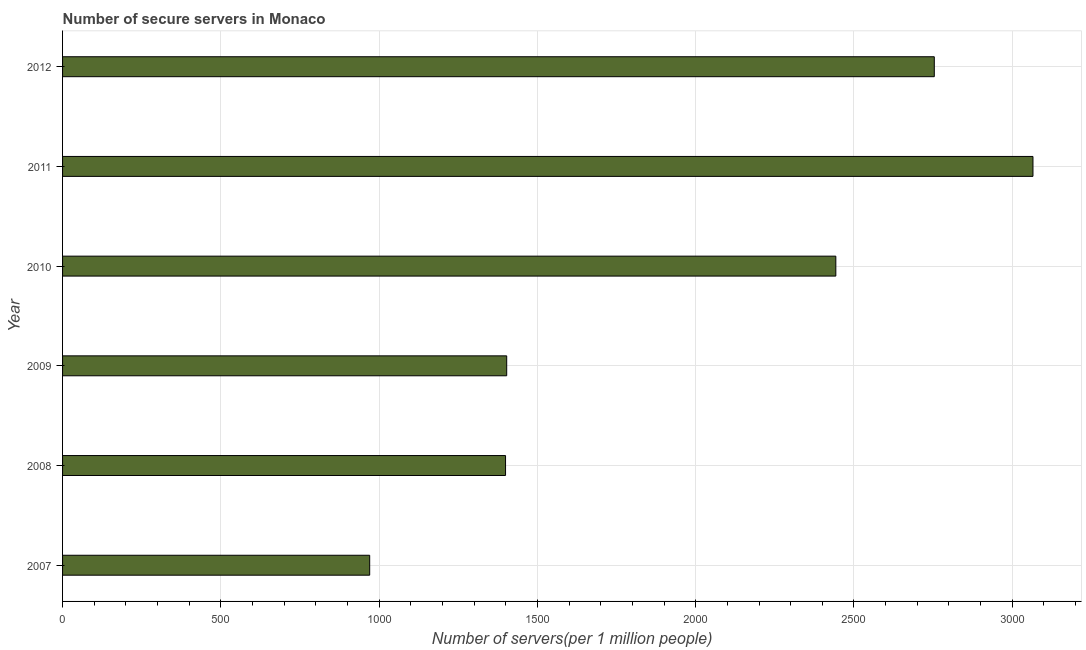Does the graph contain any zero values?
Make the answer very short. No. Does the graph contain grids?
Offer a terse response. Yes. What is the title of the graph?
Give a very brief answer. Number of secure servers in Monaco. What is the label or title of the X-axis?
Offer a very short reply. Number of servers(per 1 million people). What is the number of secure internet servers in 2008?
Keep it short and to the point. 1399.35. Across all years, what is the maximum number of secure internet servers?
Provide a succinct answer. 3065.42. Across all years, what is the minimum number of secure internet servers?
Make the answer very short. 970.15. In which year was the number of secure internet servers minimum?
Offer a terse response. 2007. What is the sum of the number of secure internet servers?
Make the answer very short. 1.20e+04. What is the difference between the number of secure internet servers in 2011 and 2012?
Offer a terse response. 311.71. What is the average number of secure internet servers per year?
Offer a very short reply. 2005.71. What is the median number of secure internet servers?
Give a very brief answer. 1922.83. In how many years, is the number of secure internet servers greater than 1900 ?
Keep it short and to the point. 3. What is the ratio of the number of secure internet servers in 2008 to that in 2012?
Your answer should be compact. 0.51. Is the number of secure internet servers in 2007 less than that in 2011?
Ensure brevity in your answer.  Yes. What is the difference between the highest and the second highest number of secure internet servers?
Your answer should be very brief. 311.71. Is the sum of the number of secure internet servers in 2010 and 2012 greater than the maximum number of secure internet servers across all years?
Ensure brevity in your answer.  Yes. What is the difference between the highest and the lowest number of secure internet servers?
Make the answer very short. 2095.27. How many bars are there?
Offer a terse response. 6. How many years are there in the graph?
Your answer should be very brief. 6. What is the Number of servers(per 1 million people) in 2007?
Offer a very short reply. 970.15. What is the Number of servers(per 1 million people) of 2008?
Keep it short and to the point. 1399.35. What is the Number of servers(per 1 million people) of 2009?
Offer a terse response. 1402.99. What is the Number of servers(per 1 million people) in 2010?
Give a very brief answer. 2442.67. What is the Number of servers(per 1 million people) in 2011?
Ensure brevity in your answer.  3065.42. What is the Number of servers(per 1 million people) of 2012?
Your response must be concise. 2753.72. What is the difference between the Number of servers(per 1 million people) in 2007 and 2008?
Keep it short and to the point. -429.19. What is the difference between the Number of servers(per 1 million people) in 2007 and 2009?
Your answer should be very brief. -432.83. What is the difference between the Number of servers(per 1 million people) in 2007 and 2010?
Give a very brief answer. -1472.51. What is the difference between the Number of servers(per 1 million people) in 2007 and 2011?
Offer a terse response. -2095.27. What is the difference between the Number of servers(per 1 million people) in 2007 and 2012?
Keep it short and to the point. -1783.56. What is the difference between the Number of servers(per 1 million people) in 2008 and 2009?
Provide a short and direct response. -3.64. What is the difference between the Number of servers(per 1 million people) in 2008 and 2010?
Your response must be concise. -1043.32. What is the difference between the Number of servers(per 1 million people) in 2008 and 2011?
Give a very brief answer. -1666.08. What is the difference between the Number of servers(per 1 million people) in 2008 and 2012?
Your response must be concise. -1354.37. What is the difference between the Number of servers(per 1 million people) in 2009 and 2010?
Offer a terse response. -1039.68. What is the difference between the Number of servers(per 1 million people) in 2009 and 2011?
Provide a succinct answer. -1662.44. What is the difference between the Number of servers(per 1 million people) in 2009 and 2012?
Your response must be concise. -1350.73. What is the difference between the Number of servers(per 1 million people) in 2010 and 2011?
Ensure brevity in your answer.  -622.76. What is the difference between the Number of servers(per 1 million people) in 2010 and 2012?
Provide a short and direct response. -311.05. What is the difference between the Number of servers(per 1 million people) in 2011 and 2012?
Keep it short and to the point. 311.71. What is the ratio of the Number of servers(per 1 million people) in 2007 to that in 2008?
Provide a succinct answer. 0.69. What is the ratio of the Number of servers(per 1 million people) in 2007 to that in 2009?
Your response must be concise. 0.69. What is the ratio of the Number of servers(per 1 million people) in 2007 to that in 2010?
Provide a succinct answer. 0.4. What is the ratio of the Number of servers(per 1 million people) in 2007 to that in 2011?
Offer a terse response. 0.32. What is the ratio of the Number of servers(per 1 million people) in 2007 to that in 2012?
Provide a short and direct response. 0.35. What is the ratio of the Number of servers(per 1 million people) in 2008 to that in 2009?
Offer a very short reply. 1. What is the ratio of the Number of servers(per 1 million people) in 2008 to that in 2010?
Provide a succinct answer. 0.57. What is the ratio of the Number of servers(per 1 million people) in 2008 to that in 2011?
Your response must be concise. 0.46. What is the ratio of the Number of servers(per 1 million people) in 2008 to that in 2012?
Your answer should be very brief. 0.51. What is the ratio of the Number of servers(per 1 million people) in 2009 to that in 2010?
Give a very brief answer. 0.57. What is the ratio of the Number of servers(per 1 million people) in 2009 to that in 2011?
Make the answer very short. 0.46. What is the ratio of the Number of servers(per 1 million people) in 2009 to that in 2012?
Offer a very short reply. 0.51. What is the ratio of the Number of servers(per 1 million people) in 2010 to that in 2011?
Make the answer very short. 0.8. What is the ratio of the Number of servers(per 1 million people) in 2010 to that in 2012?
Provide a short and direct response. 0.89. What is the ratio of the Number of servers(per 1 million people) in 2011 to that in 2012?
Your response must be concise. 1.11. 